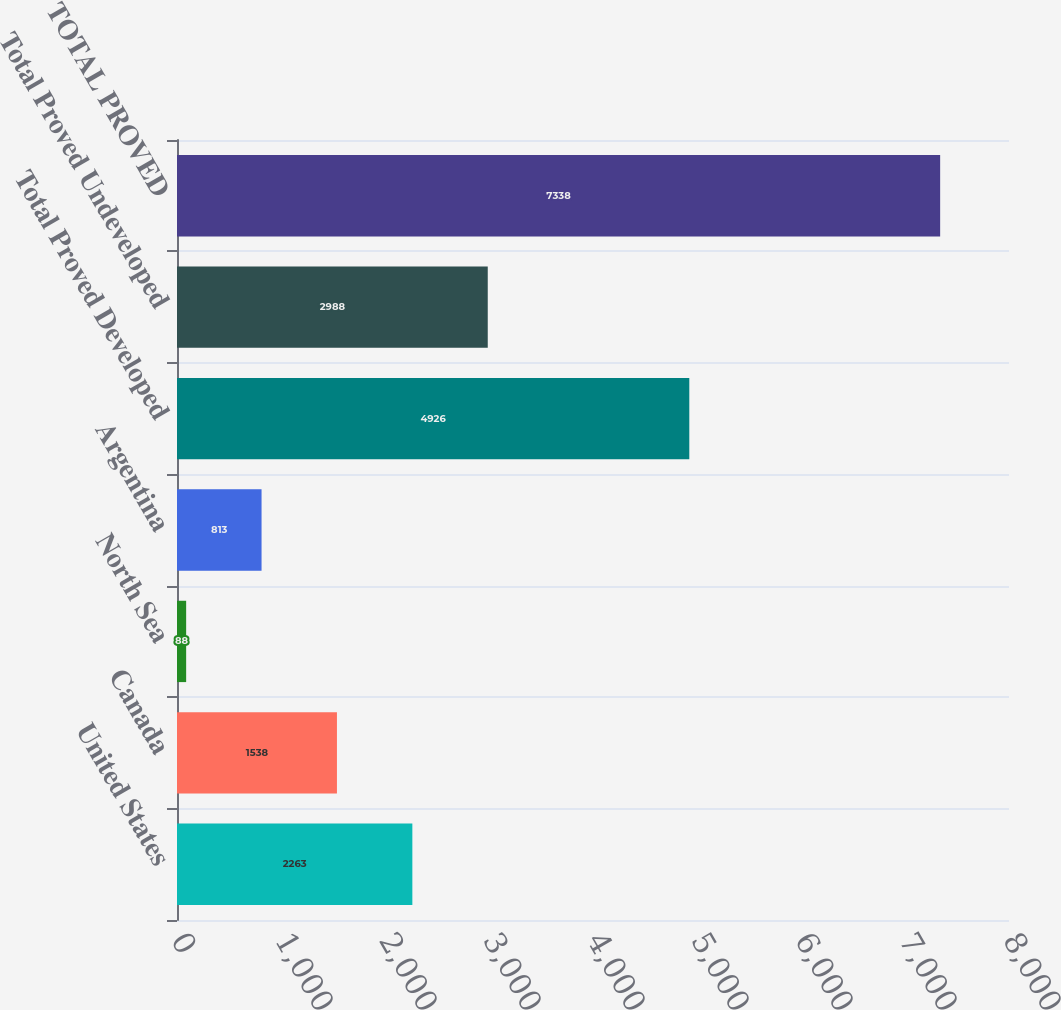<chart> <loc_0><loc_0><loc_500><loc_500><bar_chart><fcel>United States<fcel>Canada<fcel>North Sea<fcel>Argentina<fcel>Total Proved Developed<fcel>Total Proved Undeveloped<fcel>TOTAL PROVED<nl><fcel>2263<fcel>1538<fcel>88<fcel>813<fcel>4926<fcel>2988<fcel>7338<nl></chart> 